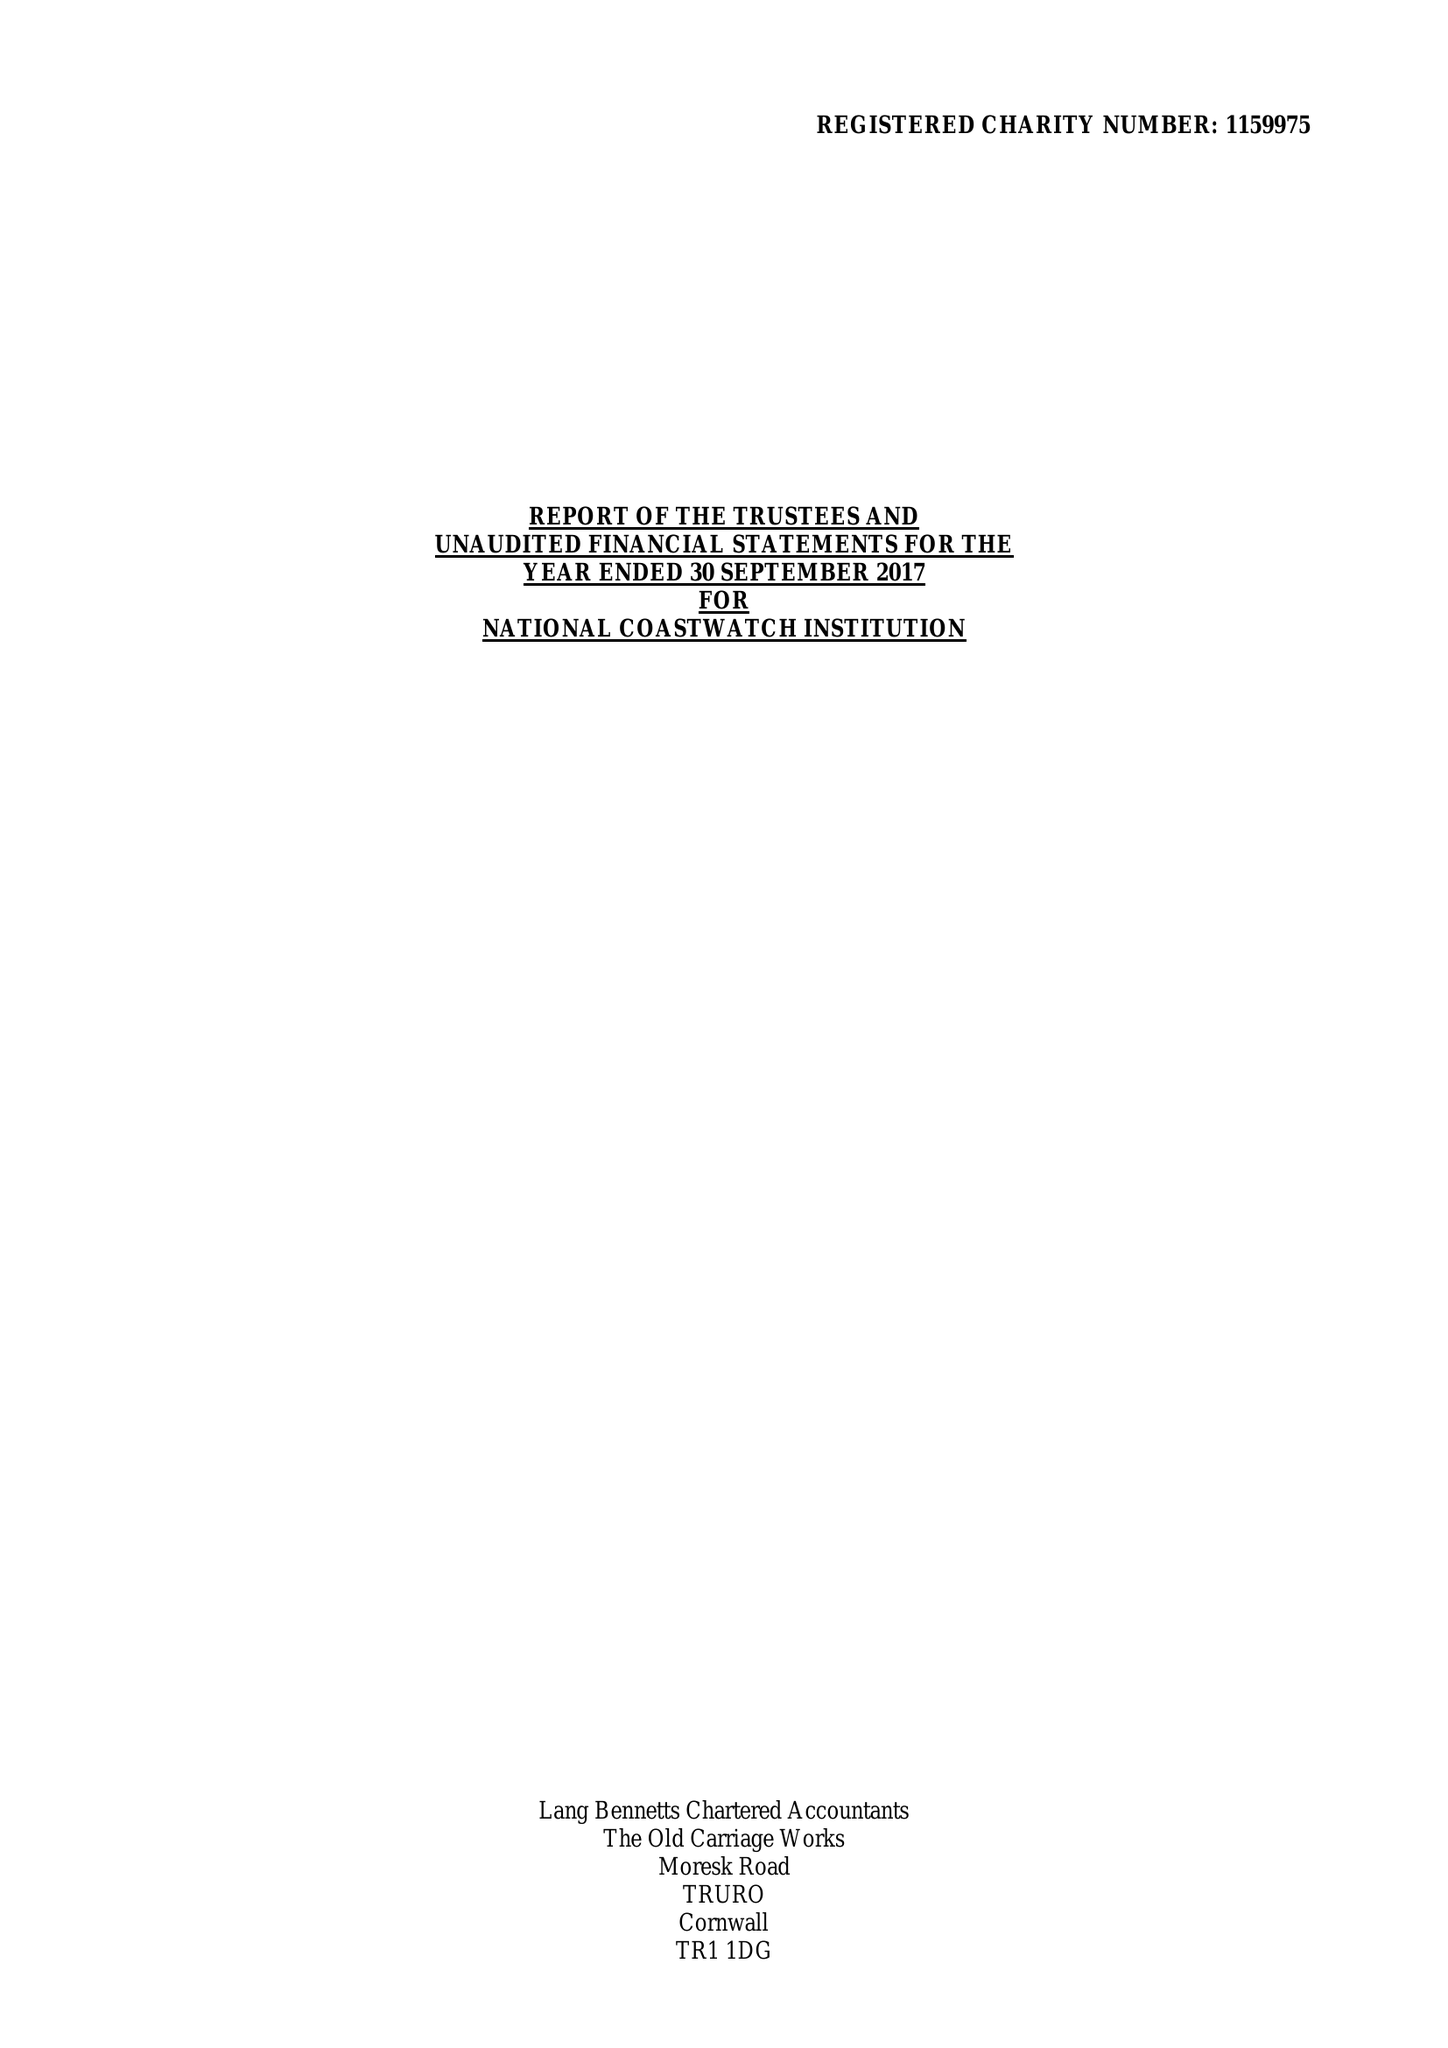What is the value for the address__post_town?
Answer the question using a single word or phrase. LISKEARD 